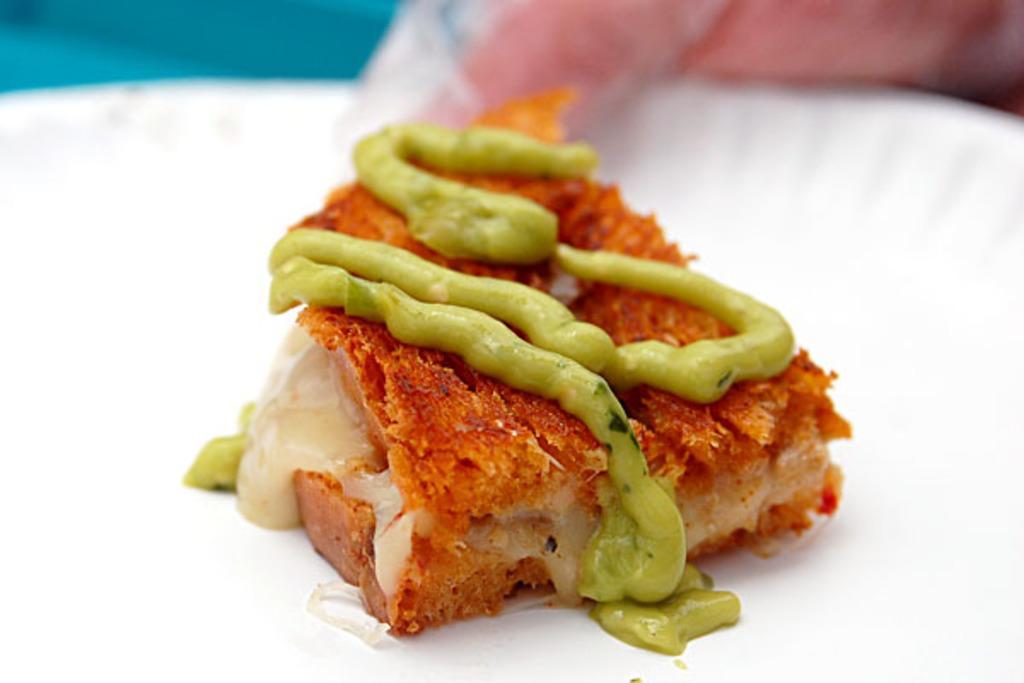In one or two sentences, can you explain what this image depicts? This is a zoomed picture. In the center there is a white color plate containing some food item. In the background we can see a pink color object. 